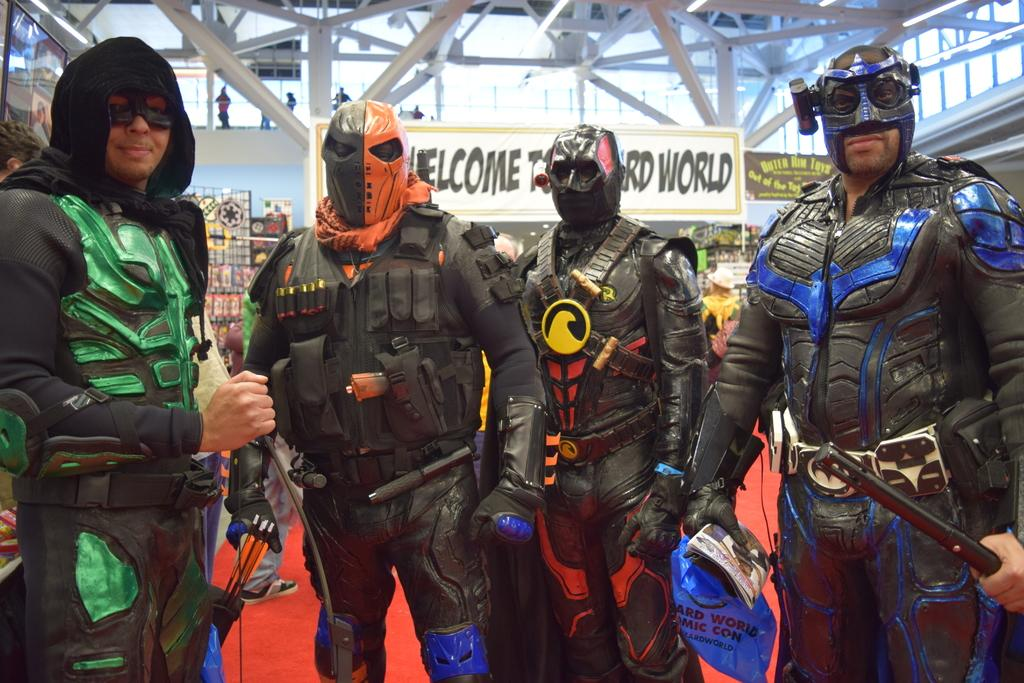How many people are in the image? There are four members in the image. What are the members wearing? All the members are wearing costumes. What can be seen in the background of the image? There is a white color board in the background of the image. Where is the circle of ants located in the image? There is no circle of ants present in the image. What type of hall can be seen in the image? There is no hall present in the image. 